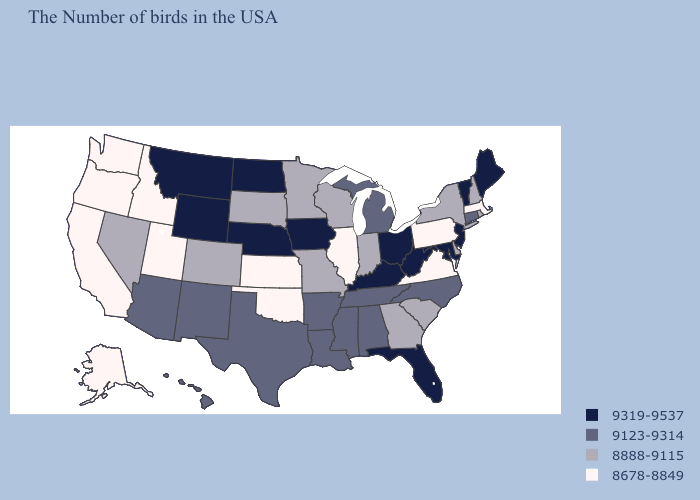Does Hawaii have a higher value than Louisiana?
Short answer required. No. Among the states that border Minnesota , does Wisconsin have the highest value?
Write a very short answer. No. Name the states that have a value in the range 9123-9314?
Quick response, please. Connecticut, North Carolina, Michigan, Alabama, Tennessee, Mississippi, Louisiana, Arkansas, Texas, New Mexico, Arizona, Hawaii. Which states have the lowest value in the USA?
Short answer required. Massachusetts, Pennsylvania, Virginia, Illinois, Kansas, Oklahoma, Utah, Idaho, California, Washington, Oregon, Alaska. What is the highest value in states that border Pennsylvania?
Quick response, please. 9319-9537. Does the first symbol in the legend represent the smallest category?
Quick response, please. No. Among the states that border Maryland , does West Virginia have the highest value?
Answer briefly. Yes. What is the value of Alaska?
Answer briefly. 8678-8849. Name the states that have a value in the range 8888-9115?
Give a very brief answer. Rhode Island, New Hampshire, New York, Delaware, South Carolina, Georgia, Indiana, Wisconsin, Missouri, Minnesota, South Dakota, Colorado, Nevada. Among the states that border California , does Oregon have the highest value?
Quick response, please. No. What is the value of North Dakota?
Be succinct. 9319-9537. What is the value of Minnesota?
Write a very short answer. 8888-9115. Among the states that border Maryland , which have the lowest value?
Quick response, please. Pennsylvania, Virginia. Name the states that have a value in the range 9123-9314?
Be succinct. Connecticut, North Carolina, Michigan, Alabama, Tennessee, Mississippi, Louisiana, Arkansas, Texas, New Mexico, Arizona, Hawaii. Name the states that have a value in the range 9123-9314?
Write a very short answer. Connecticut, North Carolina, Michigan, Alabama, Tennessee, Mississippi, Louisiana, Arkansas, Texas, New Mexico, Arizona, Hawaii. 